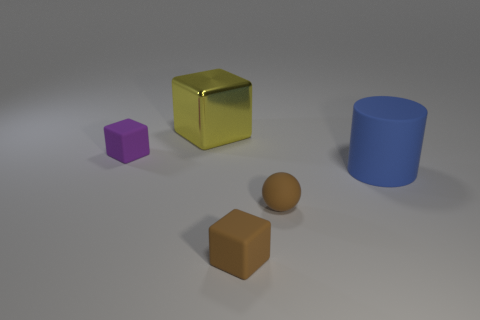Describe the textures of the objects shown. The objects exhibit a variety of textures. The gold cube and the purple cube have smooth and slightly reflective surfaces. The blue cylinder appears to have a matte finish, whereas the small rubber sphere and the brown cube have a more diffused, non-reflective texture, giving them a softer appearance. 